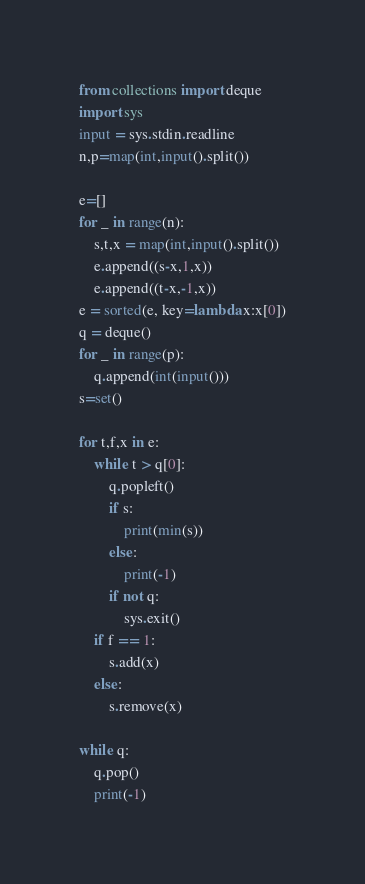<code> <loc_0><loc_0><loc_500><loc_500><_Python_>from collections import deque
import sys
input = sys.stdin.readline
n,p=map(int,input().split())

e=[]
for _ in range(n):
    s,t,x = map(int,input().split())
    e.append((s-x,1,x))
    e.append((t-x,-1,x))
e = sorted(e, key=lambda x:x[0])
q = deque()
for _ in range(p):
    q.append(int(input()))
s=set()

for t,f,x in e:
    while t > q[0]:
        q.popleft()
        if s:
            print(min(s))
        else:
            print(-1)
        if not q:
            sys.exit()
    if f == 1:
        s.add(x)
    else:
        s.remove(x)
        
while q:
    q.pop()
    print(-1)
</code> 